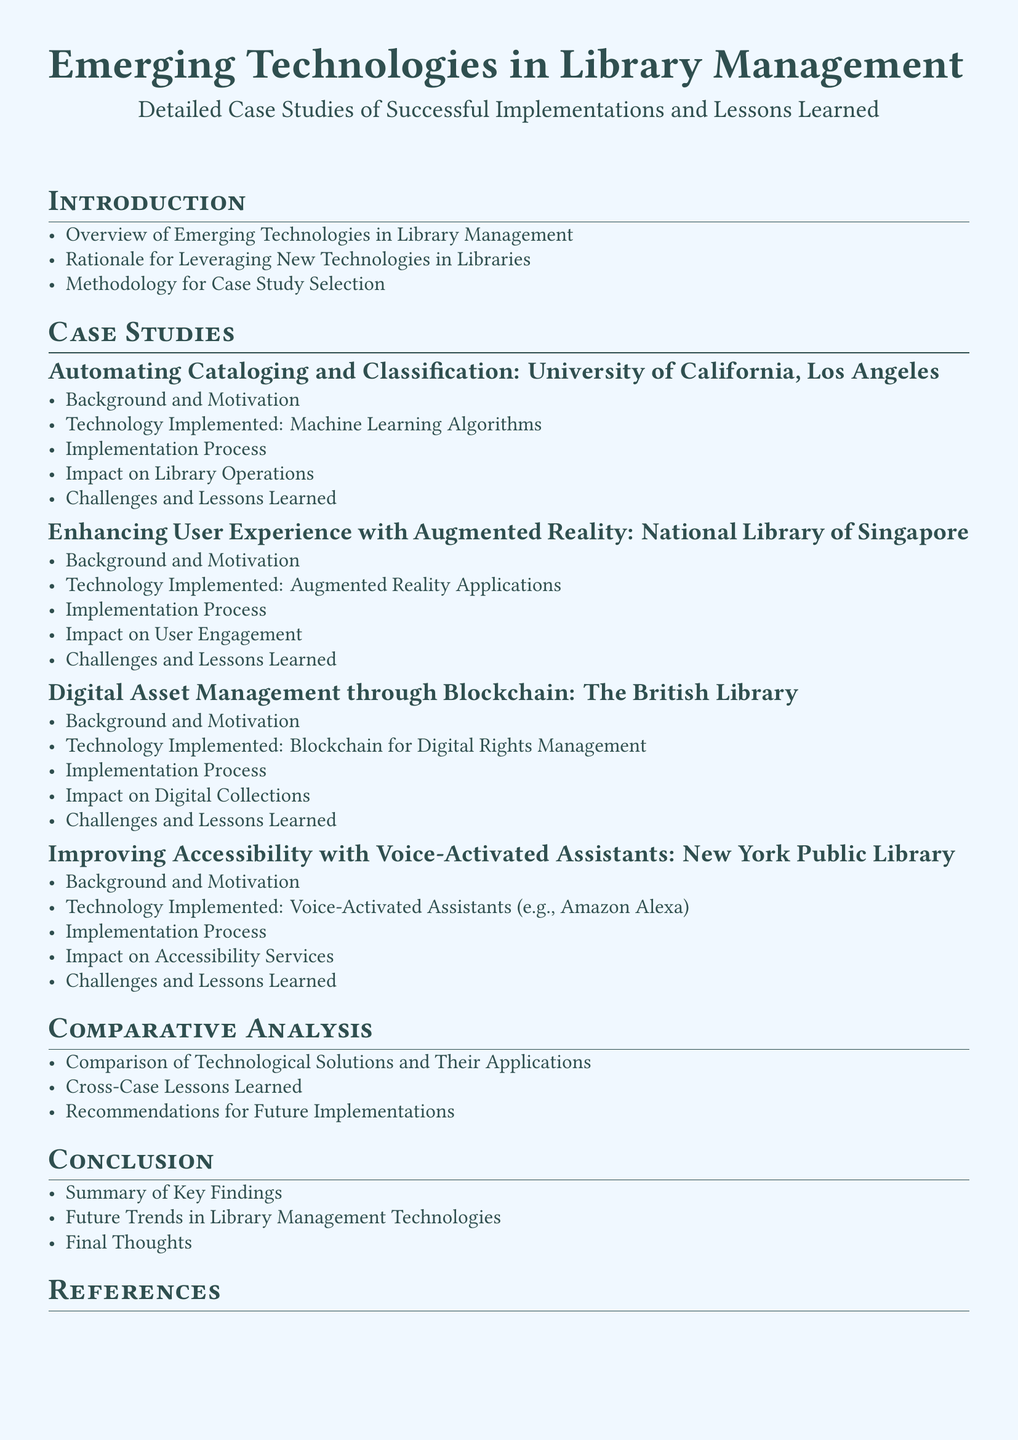What is the title of the document? The title is the main heading that represents the subject matter, which appears prominently at the beginning of the document.
Answer: Emerging Technologies in Library Management What are the three sub-sections under "Case Studies"? The sub-sections reflect key areas of study conducted within the document, specifically focused on the implementation of technologies in libraries.
Answer: Automating Cataloging and Classification, Enhancing User Experience with Augmented Reality, Digital Asset Management through Blockchain, Improving Accessibility with Voice-Activated Assistants What technology was implemented at the British Library? This refers to the specific technology used to enhance digital asset management practices as detailed in the case study.
Answer: Blockchain for Digital Rights Management How many case studies are presented in this document? This is the count of individual topics covered in the "Case Studies" section, which highlights different implementations.
Answer: Four What is one of the challenges faced in enhancing user experience with augmented reality? This question focuses on the difficulties encountered in the specific case regarding augmented reality applications, highlighted in the case study.
Answer: Challenges and Lessons Learned What is the focus area discussed in the "Comparative Analysis" section? This refers to the central theme that encompasses the various points of discussion in this section of the document.
Answer: Comparison of Technological Solutions and Their Applications What section concludes the document? The final section typically summarizes the findings and reflects on the implications of the findings presented.
Answer: Conclusion 